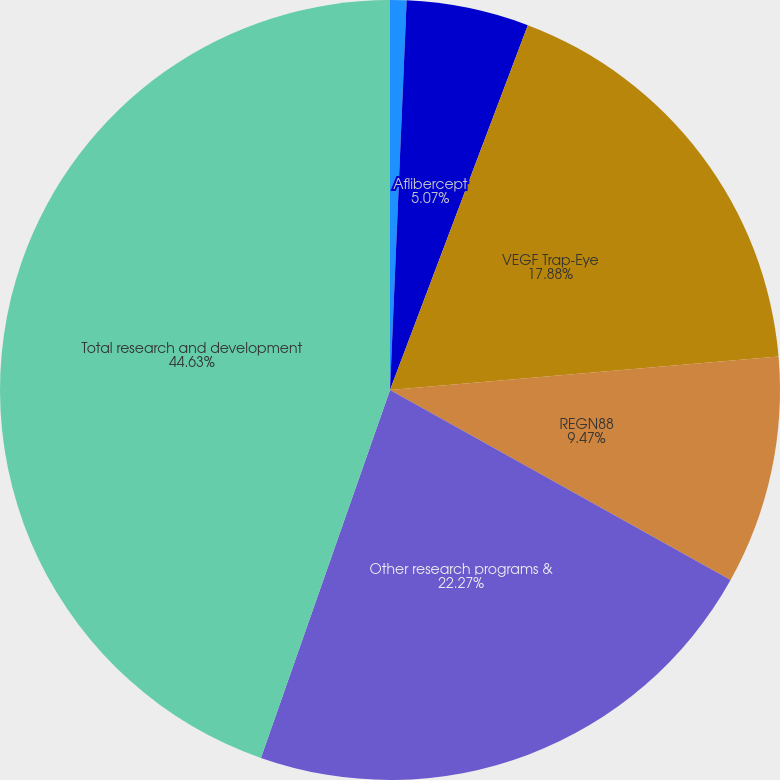Convert chart to OTSL. <chart><loc_0><loc_0><loc_500><loc_500><pie_chart><fcel>Rilonacept<fcel>Aflibercept<fcel>VEGF Trap-Eye<fcel>REGN88<fcel>Other research programs &<fcel>Total research and development<nl><fcel>0.68%<fcel>5.07%<fcel>17.88%<fcel>9.47%<fcel>22.27%<fcel>44.63%<nl></chart> 